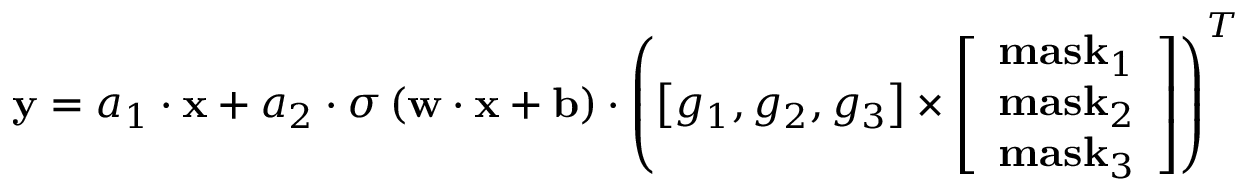Convert formula to latex. <formula><loc_0><loc_0><loc_500><loc_500>{ y } = { a _ { 1 } } \cdot { x } + { a _ { 2 } } \cdot \sigma \left ( { { w } \cdot { x } + { b } } \right ) \cdot { \left ( { \left [ { { g _ { 1 } } , { g _ { 2 } } , { g _ { 3 } } } \right ] \times \left [ \begin{array} { l } { { m a s } { { k } _ { 1 } } } \\ { { m a s } { { k } _ { 2 } } } \\ { { m a s } { { k } _ { 3 } } } \end{array} \right ] } \right ) ^ { T } }</formula> 